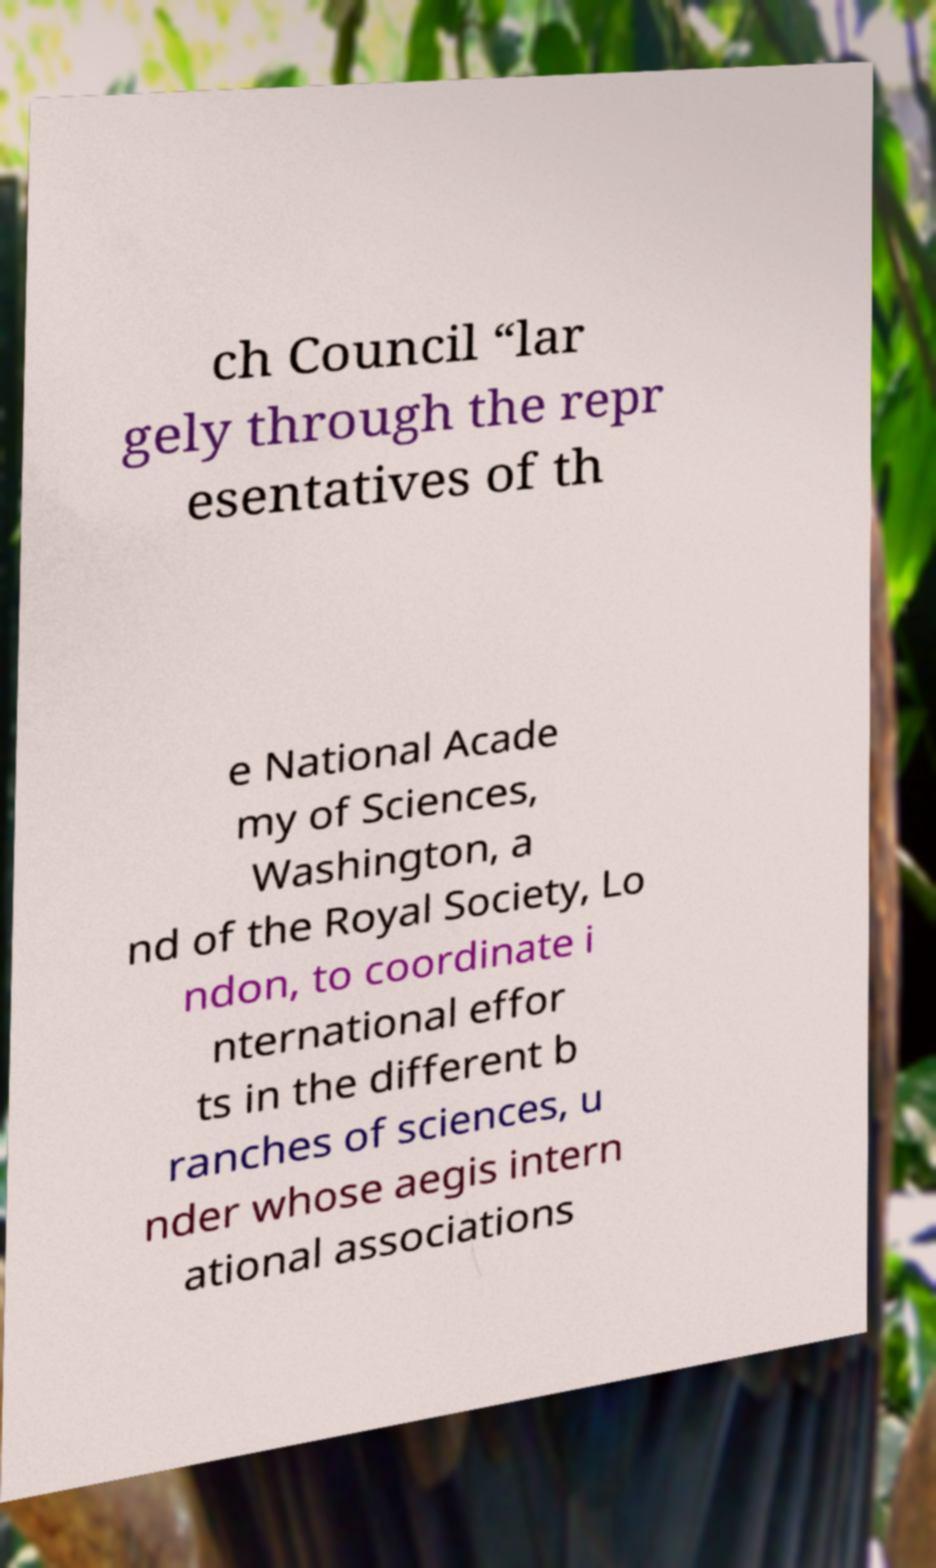For documentation purposes, I need the text within this image transcribed. Could you provide that? ch Council “lar gely through the repr esentatives of th e National Acade my of Sciences, Washington, a nd of the Royal Society, Lo ndon, to coordinate i nternational effor ts in the different b ranches of sciences, u nder whose aegis intern ational associations 